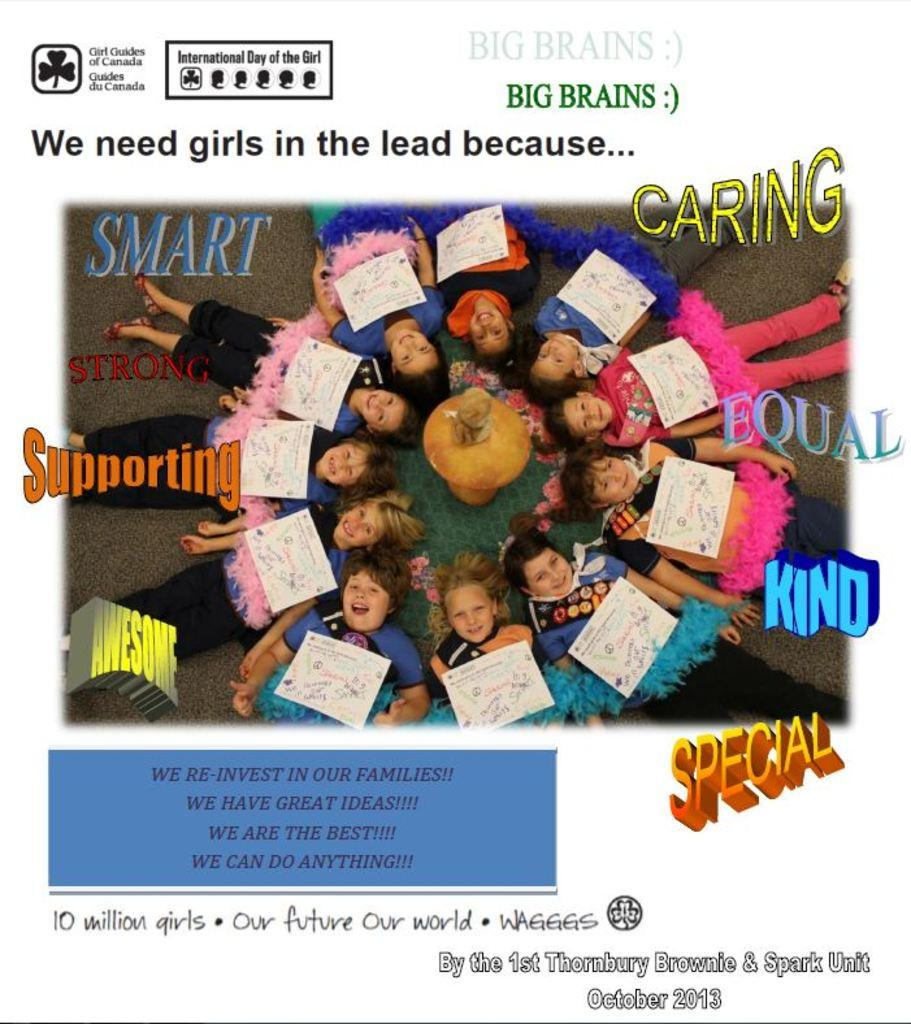What is the main subject of the poster in the image? The poster contains people. What else can be found on the poster besides the people? The poster contains text, a logo, papers, and other objects. How many bells are hanging from the logo on the poster? There are no bells present on the poster, as the facts provided do not mention any bells. What type of marble is used as a background for the poster? There is no mention of marble being used as a background for the poster, as the facts provided do not mention any marble. 